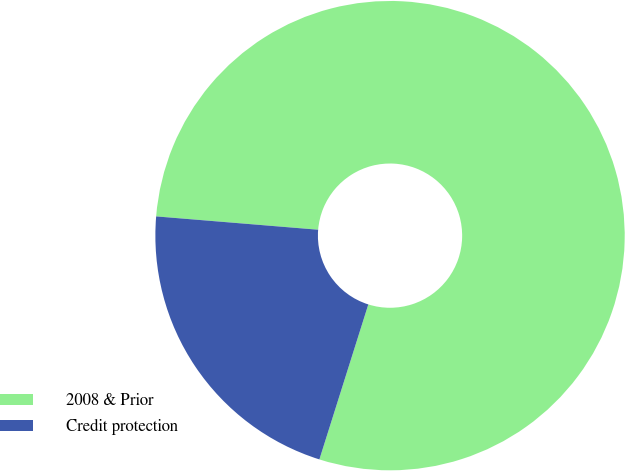Convert chart to OTSL. <chart><loc_0><loc_0><loc_500><loc_500><pie_chart><fcel>2008 & Prior<fcel>Credit protection<nl><fcel>78.56%<fcel>21.44%<nl></chart> 